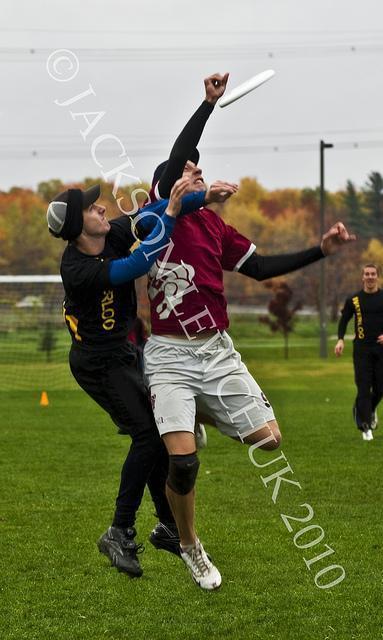How many people are on the ground?
Give a very brief answer. 1. How many feet are in the air?
Give a very brief answer. 4. How many frisbees is the man holding?
Give a very brief answer. 1. How many people are in the picture?
Give a very brief answer. 3. 